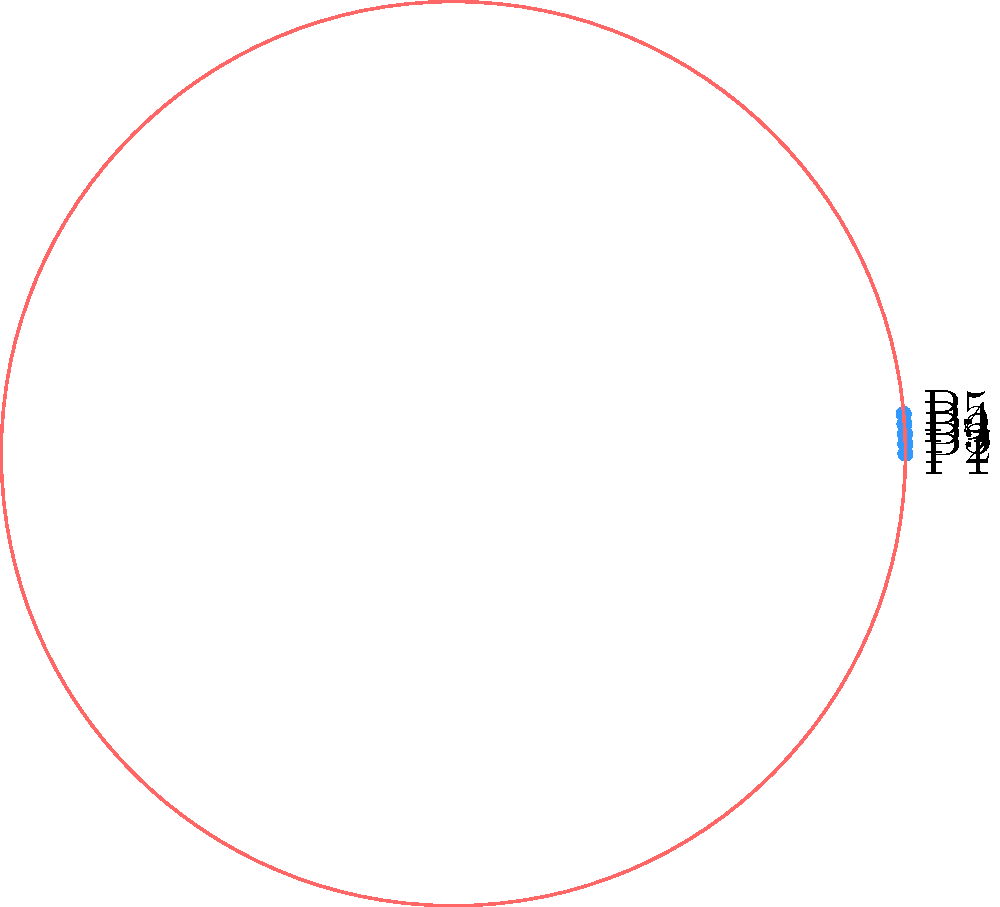Consider a cyclic group of order 5 representing a vulnerability patching schedule for five servers (P1, P2, P3, P4, P5). If the current patching order is [P1, P2, P3, P4, P5] and you apply the group operation twice, what will be the new order of patching? To solve this problem, we need to follow these steps:

1. Understand the cyclic group representation:
   - The servers are represented as elements of a cyclic group of order 5.
   - The group operation represents a rotation in the patching schedule.

2. Identify the initial state:
   - The current order is [P1, P2, P3, P4, P5].

3. Apply the group operation once:
   - This shifts each element one position to the left (cyclically).
   - After one operation: [P2, P3, P4, P5, P1]

4. Apply the group operation a second time:
   - This shifts the elements one more position to the left.
   - After the second operation: [P3, P4, P5, P1, P2]

5. Conclude:
   - The new order after applying the group operation twice is [P3, P4, P5, P1, P2].

This rotation ensures that each server gets patched in a fair and predictable order, which is crucial for maintaining consistent security across all systems.
Answer: [P3, P4, P5, P1, P2] 